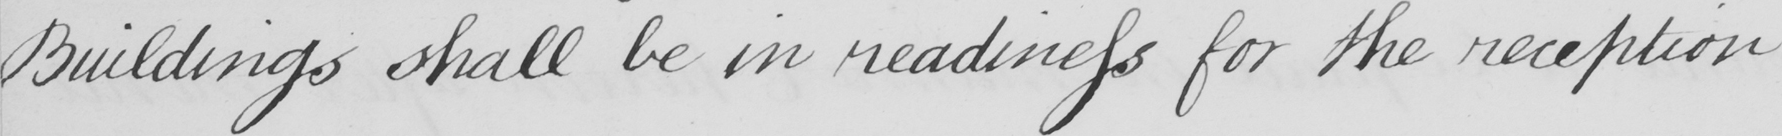What does this handwritten line say? Buildings shall be in readiness for the reception 